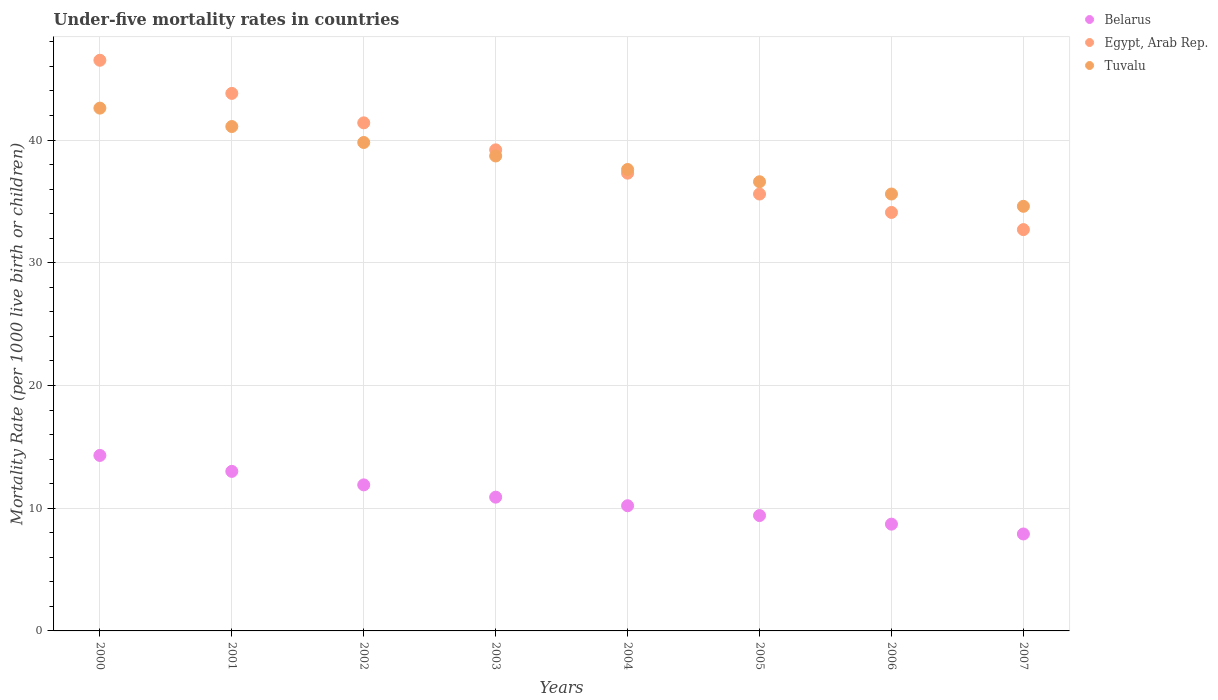What is the under-five mortality rate in Tuvalu in 2002?
Give a very brief answer. 39.8. Across all years, what is the maximum under-five mortality rate in Tuvalu?
Provide a short and direct response. 42.6. In which year was the under-five mortality rate in Tuvalu maximum?
Offer a very short reply. 2000. In which year was the under-five mortality rate in Egypt, Arab Rep. minimum?
Your answer should be very brief. 2007. What is the total under-five mortality rate in Egypt, Arab Rep. in the graph?
Provide a succinct answer. 310.6. What is the difference between the under-five mortality rate in Belarus in 2002 and that in 2006?
Offer a terse response. 3.2. What is the difference between the under-five mortality rate in Tuvalu in 2002 and the under-five mortality rate in Egypt, Arab Rep. in 2003?
Offer a very short reply. 0.6. What is the average under-five mortality rate in Tuvalu per year?
Offer a terse response. 38.33. In the year 2005, what is the difference between the under-five mortality rate in Egypt, Arab Rep. and under-five mortality rate in Belarus?
Your response must be concise. 26.2. What is the ratio of the under-five mortality rate in Tuvalu in 2004 to that in 2005?
Offer a very short reply. 1.03. Is the under-five mortality rate in Egypt, Arab Rep. in 2000 less than that in 2003?
Provide a succinct answer. No. Is the difference between the under-five mortality rate in Egypt, Arab Rep. in 2002 and 2003 greater than the difference between the under-five mortality rate in Belarus in 2002 and 2003?
Your answer should be very brief. Yes. What is the difference between the highest and the second highest under-five mortality rate in Egypt, Arab Rep.?
Your answer should be very brief. 2.7. In how many years, is the under-five mortality rate in Egypt, Arab Rep. greater than the average under-five mortality rate in Egypt, Arab Rep. taken over all years?
Offer a terse response. 4. Is the sum of the under-five mortality rate in Tuvalu in 2002 and 2004 greater than the maximum under-five mortality rate in Egypt, Arab Rep. across all years?
Keep it short and to the point. Yes. Is the under-five mortality rate in Egypt, Arab Rep. strictly greater than the under-five mortality rate in Tuvalu over the years?
Give a very brief answer. No. Is the under-five mortality rate in Egypt, Arab Rep. strictly less than the under-five mortality rate in Tuvalu over the years?
Make the answer very short. No. How many dotlines are there?
Provide a succinct answer. 3. How are the legend labels stacked?
Offer a very short reply. Vertical. What is the title of the graph?
Your response must be concise. Under-five mortality rates in countries. Does "Bolivia" appear as one of the legend labels in the graph?
Your response must be concise. No. What is the label or title of the Y-axis?
Keep it short and to the point. Mortality Rate (per 1000 live birth or children). What is the Mortality Rate (per 1000 live birth or children) of Egypt, Arab Rep. in 2000?
Provide a short and direct response. 46.5. What is the Mortality Rate (per 1000 live birth or children) in Tuvalu in 2000?
Keep it short and to the point. 42.6. What is the Mortality Rate (per 1000 live birth or children) of Belarus in 2001?
Make the answer very short. 13. What is the Mortality Rate (per 1000 live birth or children) in Egypt, Arab Rep. in 2001?
Your answer should be very brief. 43.8. What is the Mortality Rate (per 1000 live birth or children) in Tuvalu in 2001?
Give a very brief answer. 41.1. What is the Mortality Rate (per 1000 live birth or children) of Egypt, Arab Rep. in 2002?
Provide a succinct answer. 41.4. What is the Mortality Rate (per 1000 live birth or children) in Tuvalu in 2002?
Your answer should be compact. 39.8. What is the Mortality Rate (per 1000 live birth or children) of Egypt, Arab Rep. in 2003?
Offer a very short reply. 39.2. What is the Mortality Rate (per 1000 live birth or children) in Tuvalu in 2003?
Your answer should be very brief. 38.7. What is the Mortality Rate (per 1000 live birth or children) in Egypt, Arab Rep. in 2004?
Your response must be concise. 37.3. What is the Mortality Rate (per 1000 live birth or children) in Tuvalu in 2004?
Offer a very short reply. 37.6. What is the Mortality Rate (per 1000 live birth or children) of Egypt, Arab Rep. in 2005?
Make the answer very short. 35.6. What is the Mortality Rate (per 1000 live birth or children) of Tuvalu in 2005?
Offer a very short reply. 36.6. What is the Mortality Rate (per 1000 live birth or children) of Egypt, Arab Rep. in 2006?
Your answer should be very brief. 34.1. What is the Mortality Rate (per 1000 live birth or children) of Tuvalu in 2006?
Provide a short and direct response. 35.6. What is the Mortality Rate (per 1000 live birth or children) in Belarus in 2007?
Your response must be concise. 7.9. What is the Mortality Rate (per 1000 live birth or children) in Egypt, Arab Rep. in 2007?
Offer a terse response. 32.7. What is the Mortality Rate (per 1000 live birth or children) in Tuvalu in 2007?
Your response must be concise. 34.6. Across all years, what is the maximum Mortality Rate (per 1000 live birth or children) of Egypt, Arab Rep.?
Give a very brief answer. 46.5. Across all years, what is the maximum Mortality Rate (per 1000 live birth or children) of Tuvalu?
Your response must be concise. 42.6. Across all years, what is the minimum Mortality Rate (per 1000 live birth or children) in Belarus?
Give a very brief answer. 7.9. Across all years, what is the minimum Mortality Rate (per 1000 live birth or children) of Egypt, Arab Rep.?
Provide a succinct answer. 32.7. Across all years, what is the minimum Mortality Rate (per 1000 live birth or children) of Tuvalu?
Make the answer very short. 34.6. What is the total Mortality Rate (per 1000 live birth or children) of Belarus in the graph?
Provide a short and direct response. 86.3. What is the total Mortality Rate (per 1000 live birth or children) in Egypt, Arab Rep. in the graph?
Offer a terse response. 310.6. What is the total Mortality Rate (per 1000 live birth or children) in Tuvalu in the graph?
Offer a terse response. 306.6. What is the difference between the Mortality Rate (per 1000 live birth or children) of Belarus in 2000 and that in 2001?
Offer a very short reply. 1.3. What is the difference between the Mortality Rate (per 1000 live birth or children) in Belarus in 2000 and that in 2002?
Your response must be concise. 2.4. What is the difference between the Mortality Rate (per 1000 live birth or children) in Tuvalu in 2000 and that in 2002?
Provide a succinct answer. 2.8. What is the difference between the Mortality Rate (per 1000 live birth or children) in Tuvalu in 2000 and that in 2003?
Give a very brief answer. 3.9. What is the difference between the Mortality Rate (per 1000 live birth or children) of Belarus in 2000 and that in 2004?
Give a very brief answer. 4.1. What is the difference between the Mortality Rate (per 1000 live birth or children) of Tuvalu in 2000 and that in 2004?
Provide a short and direct response. 5. What is the difference between the Mortality Rate (per 1000 live birth or children) in Belarus in 2000 and that in 2005?
Offer a very short reply. 4.9. What is the difference between the Mortality Rate (per 1000 live birth or children) of Tuvalu in 2000 and that in 2005?
Your answer should be compact. 6. What is the difference between the Mortality Rate (per 1000 live birth or children) in Belarus in 2000 and that in 2006?
Your answer should be compact. 5.6. What is the difference between the Mortality Rate (per 1000 live birth or children) in Egypt, Arab Rep. in 2000 and that in 2006?
Provide a succinct answer. 12.4. What is the difference between the Mortality Rate (per 1000 live birth or children) in Tuvalu in 2000 and that in 2006?
Ensure brevity in your answer.  7. What is the difference between the Mortality Rate (per 1000 live birth or children) in Egypt, Arab Rep. in 2000 and that in 2007?
Give a very brief answer. 13.8. What is the difference between the Mortality Rate (per 1000 live birth or children) in Belarus in 2001 and that in 2002?
Give a very brief answer. 1.1. What is the difference between the Mortality Rate (per 1000 live birth or children) of Egypt, Arab Rep. in 2001 and that in 2003?
Provide a succinct answer. 4.6. What is the difference between the Mortality Rate (per 1000 live birth or children) of Tuvalu in 2001 and that in 2003?
Provide a short and direct response. 2.4. What is the difference between the Mortality Rate (per 1000 live birth or children) in Belarus in 2001 and that in 2004?
Your answer should be very brief. 2.8. What is the difference between the Mortality Rate (per 1000 live birth or children) of Egypt, Arab Rep. in 2001 and that in 2004?
Keep it short and to the point. 6.5. What is the difference between the Mortality Rate (per 1000 live birth or children) in Belarus in 2001 and that in 2006?
Your answer should be compact. 4.3. What is the difference between the Mortality Rate (per 1000 live birth or children) of Belarus in 2001 and that in 2007?
Provide a succinct answer. 5.1. What is the difference between the Mortality Rate (per 1000 live birth or children) in Egypt, Arab Rep. in 2001 and that in 2007?
Offer a very short reply. 11.1. What is the difference between the Mortality Rate (per 1000 live birth or children) in Belarus in 2002 and that in 2003?
Your response must be concise. 1. What is the difference between the Mortality Rate (per 1000 live birth or children) of Egypt, Arab Rep. in 2002 and that in 2003?
Your answer should be compact. 2.2. What is the difference between the Mortality Rate (per 1000 live birth or children) in Belarus in 2002 and that in 2004?
Your answer should be compact. 1.7. What is the difference between the Mortality Rate (per 1000 live birth or children) in Egypt, Arab Rep. in 2002 and that in 2004?
Your answer should be very brief. 4.1. What is the difference between the Mortality Rate (per 1000 live birth or children) of Tuvalu in 2002 and that in 2004?
Provide a succinct answer. 2.2. What is the difference between the Mortality Rate (per 1000 live birth or children) in Belarus in 2002 and that in 2005?
Ensure brevity in your answer.  2.5. What is the difference between the Mortality Rate (per 1000 live birth or children) in Egypt, Arab Rep. in 2002 and that in 2005?
Provide a succinct answer. 5.8. What is the difference between the Mortality Rate (per 1000 live birth or children) in Tuvalu in 2002 and that in 2005?
Make the answer very short. 3.2. What is the difference between the Mortality Rate (per 1000 live birth or children) of Belarus in 2002 and that in 2006?
Make the answer very short. 3.2. What is the difference between the Mortality Rate (per 1000 live birth or children) in Egypt, Arab Rep. in 2002 and that in 2006?
Provide a short and direct response. 7.3. What is the difference between the Mortality Rate (per 1000 live birth or children) in Egypt, Arab Rep. in 2002 and that in 2007?
Your answer should be very brief. 8.7. What is the difference between the Mortality Rate (per 1000 live birth or children) in Egypt, Arab Rep. in 2003 and that in 2004?
Your answer should be compact. 1.9. What is the difference between the Mortality Rate (per 1000 live birth or children) of Tuvalu in 2003 and that in 2004?
Provide a short and direct response. 1.1. What is the difference between the Mortality Rate (per 1000 live birth or children) of Belarus in 2003 and that in 2005?
Ensure brevity in your answer.  1.5. What is the difference between the Mortality Rate (per 1000 live birth or children) in Egypt, Arab Rep. in 2003 and that in 2005?
Make the answer very short. 3.6. What is the difference between the Mortality Rate (per 1000 live birth or children) in Egypt, Arab Rep. in 2003 and that in 2006?
Provide a short and direct response. 5.1. What is the difference between the Mortality Rate (per 1000 live birth or children) of Egypt, Arab Rep. in 2003 and that in 2007?
Provide a short and direct response. 6.5. What is the difference between the Mortality Rate (per 1000 live birth or children) of Egypt, Arab Rep. in 2004 and that in 2006?
Keep it short and to the point. 3.2. What is the difference between the Mortality Rate (per 1000 live birth or children) in Tuvalu in 2004 and that in 2006?
Provide a succinct answer. 2. What is the difference between the Mortality Rate (per 1000 live birth or children) in Egypt, Arab Rep. in 2004 and that in 2007?
Ensure brevity in your answer.  4.6. What is the difference between the Mortality Rate (per 1000 live birth or children) in Belarus in 2005 and that in 2006?
Your response must be concise. 0.7. What is the difference between the Mortality Rate (per 1000 live birth or children) of Tuvalu in 2005 and that in 2006?
Offer a very short reply. 1. What is the difference between the Mortality Rate (per 1000 live birth or children) in Egypt, Arab Rep. in 2005 and that in 2007?
Your answer should be compact. 2.9. What is the difference between the Mortality Rate (per 1000 live birth or children) of Belarus in 2006 and that in 2007?
Offer a terse response. 0.8. What is the difference between the Mortality Rate (per 1000 live birth or children) of Belarus in 2000 and the Mortality Rate (per 1000 live birth or children) of Egypt, Arab Rep. in 2001?
Keep it short and to the point. -29.5. What is the difference between the Mortality Rate (per 1000 live birth or children) of Belarus in 2000 and the Mortality Rate (per 1000 live birth or children) of Tuvalu in 2001?
Make the answer very short. -26.8. What is the difference between the Mortality Rate (per 1000 live birth or children) in Belarus in 2000 and the Mortality Rate (per 1000 live birth or children) in Egypt, Arab Rep. in 2002?
Offer a very short reply. -27.1. What is the difference between the Mortality Rate (per 1000 live birth or children) of Belarus in 2000 and the Mortality Rate (per 1000 live birth or children) of Tuvalu in 2002?
Ensure brevity in your answer.  -25.5. What is the difference between the Mortality Rate (per 1000 live birth or children) of Belarus in 2000 and the Mortality Rate (per 1000 live birth or children) of Egypt, Arab Rep. in 2003?
Ensure brevity in your answer.  -24.9. What is the difference between the Mortality Rate (per 1000 live birth or children) in Belarus in 2000 and the Mortality Rate (per 1000 live birth or children) in Tuvalu in 2003?
Ensure brevity in your answer.  -24.4. What is the difference between the Mortality Rate (per 1000 live birth or children) in Egypt, Arab Rep. in 2000 and the Mortality Rate (per 1000 live birth or children) in Tuvalu in 2003?
Provide a short and direct response. 7.8. What is the difference between the Mortality Rate (per 1000 live birth or children) in Belarus in 2000 and the Mortality Rate (per 1000 live birth or children) in Tuvalu in 2004?
Your response must be concise. -23.3. What is the difference between the Mortality Rate (per 1000 live birth or children) in Egypt, Arab Rep. in 2000 and the Mortality Rate (per 1000 live birth or children) in Tuvalu in 2004?
Offer a terse response. 8.9. What is the difference between the Mortality Rate (per 1000 live birth or children) in Belarus in 2000 and the Mortality Rate (per 1000 live birth or children) in Egypt, Arab Rep. in 2005?
Offer a very short reply. -21.3. What is the difference between the Mortality Rate (per 1000 live birth or children) in Belarus in 2000 and the Mortality Rate (per 1000 live birth or children) in Tuvalu in 2005?
Your answer should be compact. -22.3. What is the difference between the Mortality Rate (per 1000 live birth or children) of Egypt, Arab Rep. in 2000 and the Mortality Rate (per 1000 live birth or children) of Tuvalu in 2005?
Give a very brief answer. 9.9. What is the difference between the Mortality Rate (per 1000 live birth or children) in Belarus in 2000 and the Mortality Rate (per 1000 live birth or children) in Egypt, Arab Rep. in 2006?
Keep it short and to the point. -19.8. What is the difference between the Mortality Rate (per 1000 live birth or children) of Belarus in 2000 and the Mortality Rate (per 1000 live birth or children) of Tuvalu in 2006?
Offer a very short reply. -21.3. What is the difference between the Mortality Rate (per 1000 live birth or children) of Egypt, Arab Rep. in 2000 and the Mortality Rate (per 1000 live birth or children) of Tuvalu in 2006?
Give a very brief answer. 10.9. What is the difference between the Mortality Rate (per 1000 live birth or children) of Belarus in 2000 and the Mortality Rate (per 1000 live birth or children) of Egypt, Arab Rep. in 2007?
Keep it short and to the point. -18.4. What is the difference between the Mortality Rate (per 1000 live birth or children) in Belarus in 2000 and the Mortality Rate (per 1000 live birth or children) in Tuvalu in 2007?
Give a very brief answer. -20.3. What is the difference between the Mortality Rate (per 1000 live birth or children) in Egypt, Arab Rep. in 2000 and the Mortality Rate (per 1000 live birth or children) in Tuvalu in 2007?
Your answer should be compact. 11.9. What is the difference between the Mortality Rate (per 1000 live birth or children) of Belarus in 2001 and the Mortality Rate (per 1000 live birth or children) of Egypt, Arab Rep. in 2002?
Make the answer very short. -28.4. What is the difference between the Mortality Rate (per 1000 live birth or children) of Belarus in 2001 and the Mortality Rate (per 1000 live birth or children) of Tuvalu in 2002?
Provide a short and direct response. -26.8. What is the difference between the Mortality Rate (per 1000 live birth or children) of Belarus in 2001 and the Mortality Rate (per 1000 live birth or children) of Egypt, Arab Rep. in 2003?
Give a very brief answer. -26.2. What is the difference between the Mortality Rate (per 1000 live birth or children) of Belarus in 2001 and the Mortality Rate (per 1000 live birth or children) of Tuvalu in 2003?
Offer a terse response. -25.7. What is the difference between the Mortality Rate (per 1000 live birth or children) of Egypt, Arab Rep. in 2001 and the Mortality Rate (per 1000 live birth or children) of Tuvalu in 2003?
Offer a terse response. 5.1. What is the difference between the Mortality Rate (per 1000 live birth or children) in Belarus in 2001 and the Mortality Rate (per 1000 live birth or children) in Egypt, Arab Rep. in 2004?
Offer a very short reply. -24.3. What is the difference between the Mortality Rate (per 1000 live birth or children) of Belarus in 2001 and the Mortality Rate (per 1000 live birth or children) of Tuvalu in 2004?
Ensure brevity in your answer.  -24.6. What is the difference between the Mortality Rate (per 1000 live birth or children) in Egypt, Arab Rep. in 2001 and the Mortality Rate (per 1000 live birth or children) in Tuvalu in 2004?
Ensure brevity in your answer.  6.2. What is the difference between the Mortality Rate (per 1000 live birth or children) of Belarus in 2001 and the Mortality Rate (per 1000 live birth or children) of Egypt, Arab Rep. in 2005?
Your response must be concise. -22.6. What is the difference between the Mortality Rate (per 1000 live birth or children) in Belarus in 2001 and the Mortality Rate (per 1000 live birth or children) in Tuvalu in 2005?
Offer a very short reply. -23.6. What is the difference between the Mortality Rate (per 1000 live birth or children) of Belarus in 2001 and the Mortality Rate (per 1000 live birth or children) of Egypt, Arab Rep. in 2006?
Your answer should be very brief. -21.1. What is the difference between the Mortality Rate (per 1000 live birth or children) in Belarus in 2001 and the Mortality Rate (per 1000 live birth or children) in Tuvalu in 2006?
Give a very brief answer. -22.6. What is the difference between the Mortality Rate (per 1000 live birth or children) of Egypt, Arab Rep. in 2001 and the Mortality Rate (per 1000 live birth or children) of Tuvalu in 2006?
Provide a succinct answer. 8.2. What is the difference between the Mortality Rate (per 1000 live birth or children) in Belarus in 2001 and the Mortality Rate (per 1000 live birth or children) in Egypt, Arab Rep. in 2007?
Your answer should be compact. -19.7. What is the difference between the Mortality Rate (per 1000 live birth or children) in Belarus in 2001 and the Mortality Rate (per 1000 live birth or children) in Tuvalu in 2007?
Keep it short and to the point. -21.6. What is the difference between the Mortality Rate (per 1000 live birth or children) in Egypt, Arab Rep. in 2001 and the Mortality Rate (per 1000 live birth or children) in Tuvalu in 2007?
Provide a short and direct response. 9.2. What is the difference between the Mortality Rate (per 1000 live birth or children) of Belarus in 2002 and the Mortality Rate (per 1000 live birth or children) of Egypt, Arab Rep. in 2003?
Keep it short and to the point. -27.3. What is the difference between the Mortality Rate (per 1000 live birth or children) of Belarus in 2002 and the Mortality Rate (per 1000 live birth or children) of Tuvalu in 2003?
Make the answer very short. -26.8. What is the difference between the Mortality Rate (per 1000 live birth or children) of Egypt, Arab Rep. in 2002 and the Mortality Rate (per 1000 live birth or children) of Tuvalu in 2003?
Provide a short and direct response. 2.7. What is the difference between the Mortality Rate (per 1000 live birth or children) in Belarus in 2002 and the Mortality Rate (per 1000 live birth or children) in Egypt, Arab Rep. in 2004?
Your answer should be very brief. -25.4. What is the difference between the Mortality Rate (per 1000 live birth or children) of Belarus in 2002 and the Mortality Rate (per 1000 live birth or children) of Tuvalu in 2004?
Offer a very short reply. -25.7. What is the difference between the Mortality Rate (per 1000 live birth or children) of Belarus in 2002 and the Mortality Rate (per 1000 live birth or children) of Egypt, Arab Rep. in 2005?
Give a very brief answer. -23.7. What is the difference between the Mortality Rate (per 1000 live birth or children) in Belarus in 2002 and the Mortality Rate (per 1000 live birth or children) in Tuvalu in 2005?
Your response must be concise. -24.7. What is the difference between the Mortality Rate (per 1000 live birth or children) of Egypt, Arab Rep. in 2002 and the Mortality Rate (per 1000 live birth or children) of Tuvalu in 2005?
Make the answer very short. 4.8. What is the difference between the Mortality Rate (per 1000 live birth or children) in Belarus in 2002 and the Mortality Rate (per 1000 live birth or children) in Egypt, Arab Rep. in 2006?
Your response must be concise. -22.2. What is the difference between the Mortality Rate (per 1000 live birth or children) in Belarus in 2002 and the Mortality Rate (per 1000 live birth or children) in Tuvalu in 2006?
Make the answer very short. -23.7. What is the difference between the Mortality Rate (per 1000 live birth or children) of Egypt, Arab Rep. in 2002 and the Mortality Rate (per 1000 live birth or children) of Tuvalu in 2006?
Keep it short and to the point. 5.8. What is the difference between the Mortality Rate (per 1000 live birth or children) in Belarus in 2002 and the Mortality Rate (per 1000 live birth or children) in Egypt, Arab Rep. in 2007?
Ensure brevity in your answer.  -20.8. What is the difference between the Mortality Rate (per 1000 live birth or children) of Belarus in 2002 and the Mortality Rate (per 1000 live birth or children) of Tuvalu in 2007?
Offer a very short reply. -22.7. What is the difference between the Mortality Rate (per 1000 live birth or children) of Belarus in 2003 and the Mortality Rate (per 1000 live birth or children) of Egypt, Arab Rep. in 2004?
Your response must be concise. -26.4. What is the difference between the Mortality Rate (per 1000 live birth or children) of Belarus in 2003 and the Mortality Rate (per 1000 live birth or children) of Tuvalu in 2004?
Provide a short and direct response. -26.7. What is the difference between the Mortality Rate (per 1000 live birth or children) in Egypt, Arab Rep. in 2003 and the Mortality Rate (per 1000 live birth or children) in Tuvalu in 2004?
Your response must be concise. 1.6. What is the difference between the Mortality Rate (per 1000 live birth or children) in Belarus in 2003 and the Mortality Rate (per 1000 live birth or children) in Egypt, Arab Rep. in 2005?
Keep it short and to the point. -24.7. What is the difference between the Mortality Rate (per 1000 live birth or children) in Belarus in 2003 and the Mortality Rate (per 1000 live birth or children) in Tuvalu in 2005?
Make the answer very short. -25.7. What is the difference between the Mortality Rate (per 1000 live birth or children) of Egypt, Arab Rep. in 2003 and the Mortality Rate (per 1000 live birth or children) of Tuvalu in 2005?
Ensure brevity in your answer.  2.6. What is the difference between the Mortality Rate (per 1000 live birth or children) in Belarus in 2003 and the Mortality Rate (per 1000 live birth or children) in Egypt, Arab Rep. in 2006?
Your answer should be very brief. -23.2. What is the difference between the Mortality Rate (per 1000 live birth or children) of Belarus in 2003 and the Mortality Rate (per 1000 live birth or children) of Tuvalu in 2006?
Provide a succinct answer. -24.7. What is the difference between the Mortality Rate (per 1000 live birth or children) in Egypt, Arab Rep. in 2003 and the Mortality Rate (per 1000 live birth or children) in Tuvalu in 2006?
Your answer should be compact. 3.6. What is the difference between the Mortality Rate (per 1000 live birth or children) in Belarus in 2003 and the Mortality Rate (per 1000 live birth or children) in Egypt, Arab Rep. in 2007?
Ensure brevity in your answer.  -21.8. What is the difference between the Mortality Rate (per 1000 live birth or children) of Belarus in 2003 and the Mortality Rate (per 1000 live birth or children) of Tuvalu in 2007?
Ensure brevity in your answer.  -23.7. What is the difference between the Mortality Rate (per 1000 live birth or children) of Belarus in 2004 and the Mortality Rate (per 1000 live birth or children) of Egypt, Arab Rep. in 2005?
Keep it short and to the point. -25.4. What is the difference between the Mortality Rate (per 1000 live birth or children) in Belarus in 2004 and the Mortality Rate (per 1000 live birth or children) in Tuvalu in 2005?
Keep it short and to the point. -26.4. What is the difference between the Mortality Rate (per 1000 live birth or children) in Egypt, Arab Rep. in 2004 and the Mortality Rate (per 1000 live birth or children) in Tuvalu in 2005?
Your response must be concise. 0.7. What is the difference between the Mortality Rate (per 1000 live birth or children) of Belarus in 2004 and the Mortality Rate (per 1000 live birth or children) of Egypt, Arab Rep. in 2006?
Provide a succinct answer. -23.9. What is the difference between the Mortality Rate (per 1000 live birth or children) in Belarus in 2004 and the Mortality Rate (per 1000 live birth or children) in Tuvalu in 2006?
Your answer should be very brief. -25.4. What is the difference between the Mortality Rate (per 1000 live birth or children) in Egypt, Arab Rep. in 2004 and the Mortality Rate (per 1000 live birth or children) in Tuvalu in 2006?
Keep it short and to the point. 1.7. What is the difference between the Mortality Rate (per 1000 live birth or children) of Belarus in 2004 and the Mortality Rate (per 1000 live birth or children) of Egypt, Arab Rep. in 2007?
Give a very brief answer. -22.5. What is the difference between the Mortality Rate (per 1000 live birth or children) in Belarus in 2004 and the Mortality Rate (per 1000 live birth or children) in Tuvalu in 2007?
Provide a short and direct response. -24.4. What is the difference between the Mortality Rate (per 1000 live birth or children) of Egypt, Arab Rep. in 2004 and the Mortality Rate (per 1000 live birth or children) of Tuvalu in 2007?
Offer a very short reply. 2.7. What is the difference between the Mortality Rate (per 1000 live birth or children) in Belarus in 2005 and the Mortality Rate (per 1000 live birth or children) in Egypt, Arab Rep. in 2006?
Offer a very short reply. -24.7. What is the difference between the Mortality Rate (per 1000 live birth or children) of Belarus in 2005 and the Mortality Rate (per 1000 live birth or children) of Tuvalu in 2006?
Ensure brevity in your answer.  -26.2. What is the difference between the Mortality Rate (per 1000 live birth or children) of Belarus in 2005 and the Mortality Rate (per 1000 live birth or children) of Egypt, Arab Rep. in 2007?
Give a very brief answer. -23.3. What is the difference between the Mortality Rate (per 1000 live birth or children) in Belarus in 2005 and the Mortality Rate (per 1000 live birth or children) in Tuvalu in 2007?
Your answer should be very brief. -25.2. What is the difference between the Mortality Rate (per 1000 live birth or children) in Egypt, Arab Rep. in 2005 and the Mortality Rate (per 1000 live birth or children) in Tuvalu in 2007?
Your answer should be very brief. 1. What is the difference between the Mortality Rate (per 1000 live birth or children) of Belarus in 2006 and the Mortality Rate (per 1000 live birth or children) of Tuvalu in 2007?
Your answer should be very brief. -25.9. What is the difference between the Mortality Rate (per 1000 live birth or children) in Egypt, Arab Rep. in 2006 and the Mortality Rate (per 1000 live birth or children) in Tuvalu in 2007?
Provide a short and direct response. -0.5. What is the average Mortality Rate (per 1000 live birth or children) of Belarus per year?
Keep it short and to the point. 10.79. What is the average Mortality Rate (per 1000 live birth or children) of Egypt, Arab Rep. per year?
Ensure brevity in your answer.  38.83. What is the average Mortality Rate (per 1000 live birth or children) of Tuvalu per year?
Make the answer very short. 38.33. In the year 2000, what is the difference between the Mortality Rate (per 1000 live birth or children) of Belarus and Mortality Rate (per 1000 live birth or children) of Egypt, Arab Rep.?
Your answer should be very brief. -32.2. In the year 2000, what is the difference between the Mortality Rate (per 1000 live birth or children) of Belarus and Mortality Rate (per 1000 live birth or children) of Tuvalu?
Give a very brief answer. -28.3. In the year 2001, what is the difference between the Mortality Rate (per 1000 live birth or children) of Belarus and Mortality Rate (per 1000 live birth or children) of Egypt, Arab Rep.?
Your answer should be very brief. -30.8. In the year 2001, what is the difference between the Mortality Rate (per 1000 live birth or children) in Belarus and Mortality Rate (per 1000 live birth or children) in Tuvalu?
Give a very brief answer. -28.1. In the year 2002, what is the difference between the Mortality Rate (per 1000 live birth or children) of Belarus and Mortality Rate (per 1000 live birth or children) of Egypt, Arab Rep.?
Provide a succinct answer. -29.5. In the year 2002, what is the difference between the Mortality Rate (per 1000 live birth or children) in Belarus and Mortality Rate (per 1000 live birth or children) in Tuvalu?
Keep it short and to the point. -27.9. In the year 2002, what is the difference between the Mortality Rate (per 1000 live birth or children) of Egypt, Arab Rep. and Mortality Rate (per 1000 live birth or children) of Tuvalu?
Ensure brevity in your answer.  1.6. In the year 2003, what is the difference between the Mortality Rate (per 1000 live birth or children) of Belarus and Mortality Rate (per 1000 live birth or children) of Egypt, Arab Rep.?
Your response must be concise. -28.3. In the year 2003, what is the difference between the Mortality Rate (per 1000 live birth or children) of Belarus and Mortality Rate (per 1000 live birth or children) of Tuvalu?
Provide a succinct answer. -27.8. In the year 2004, what is the difference between the Mortality Rate (per 1000 live birth or children) in Belarus and Mortality Rate (per 1000 live birth or children) in Egypt, Arab Rep.?
Your response must be concise. -27.1. In the year 2004, what is the difference between the Mortality Rate (per 1000 live birth or children) of Belarus and Mortality Rate (per 1000 live birth or children) of Tuvalu?
Ensure brevity in your answer.  -27.4. In the year 2004, what is the difference between the Mortality Rate (per 1000 live birth or children) in Egypt, Arab Rep. and Mortality Rate (per 1000 live birth or children) in Tuvalu?
Offer a very short reply. -0.3. In the year 2005, what is the difference between the Mortality Rate (per 1000 live birth or children) of Belarus and Mortality Rate (per 1000 live birth or children) of Egypt, Arab Rep.?
Offer a very short reply. -26.2. In the year 2005, what is the difference between the Mortality Rate (per 1000 live birth or children) of Belarus and Mortality Rate (per 1000 live birth or children) of Tuvalu?
Your answer should be very brief. -27.2. In the year 2005, what is the difference between the Mortality Rate (per 1000 live birth or children) in Egypt, Arab Rep. and Mortality Rate (per 1000 live birth or children) in Tuvalu?
Keep it short and to the point. -1. In the year 2006, what is the difference between the Mortality Rate (per 1000 live birth or children) in Belarus and Mortality Rate (per 1000 live birth or children) in Egypt, Arab Rep.?
Offer a very short reply. -25.4. In the year 2006, what is the difference between the Mortality Rate (per 1000 live birth or children) of Belarus and Mortality Rate (per 1000 live birth or children) of Tuvalu?
Provide a succinct answer. -26.9. In the year 2006, what is the difference between the Mortality Rate (per 1000 live birth or children) in Egypt, Arab Rep. and Mortality Rate (per 1000 live birth or children) in Tuvalu?
Provide a succinct answer. -1.5. In the year 2007, what is the difference between the Mortality Rate (per 1000 live birth or children) of Belarus and Mortality Rate (per 1000 live birth or children) of Egypt, Arab Rep.?
Keep it short and to the point. -24.8. In the year 2007, what is the difference between the Mortality Rate (per 1000 live birth or children) of Belarus and Mortality Rate (per 1000 live birth or children) of Tuvalu?
Offer a very short reply. -26.7. What is the ratio of the Mortality Rate (per 1000 live birth or children) in Egypt, Arab Rep. in 2000 to that in 2001?
Your response must be concise. 1.06. What is the ratio of the Mortality Rate (per 1000 live birth or children) of Tuvalu in 2000 to that in 2001?
Provide a short and direct response. 1.04. What is the ratio of the Mortality Rate (per 1000 live birth or children) of Belarus in 2000 to that in 2002?
Provide a succinct answer. 1.2. What is the ratio of the Mortality Rate (per 1000 live birth or children) of Egypt, Arab Rep. in 2000 to that in 2002?
Your answer should be compact. 1.12. What is the ratio of the Mortality Rate (per 1000 live birth or children) of Tuvalu in 2000 to that in 2002?
Give a very brief answer. 1.07. What is the ratio of the Mortality Rate (per 1000 live birth or children) in Belarus in 2000 to that in 2003?
Make the answer very short. 1.31. What is the ratio of the Mortality Rate (per 1000 live birth or children) in Egypt, Arab Rep. in 2000 to that in 2003?
Provide a short and direct response. 1.19. What is the ratio of the Mortality Rate (per 1000 live birth or children) in Tuvalu in 2000 to that in 2003?
Offer a terse response. 1.1. What is the ratio of the Mortality Rate (per 1000 live birth or children) of Belarus in 2000 to that in 2004?
Your answer should be compact. 1.4. What is the ratio of the Mortality Rate (per 1000 live birth or children) in Egypt, Arab Rep. in 2000 to that in 2004?
Your answer should be compact. 1.25. What is the ratio of the Mortality Rate (per 1000 live birth or children) of Tuvalu in 2000 to that in 2004?
Ensure brevity in your answer.  1.13. What is the ratio of the Mortality Rate (per 1000 live birth or children) in Belarus in 2000 to that in 2005?
Ensure brevity in your answer.  1.52. What is the ratio of the Mortality Rate (per 1000 live birth or children) in Egypt, Arab Rep. in 2000 to that in 2005?
Keep it short and to the point. 1.31. What is the ratio of the Mortality Rate (per 1000 live birth or children) of Tuvalu in 2000 to that in 2005?
Keep it short and to the point. 1.16. What is the ratio of the Mortality Rate (per 1000 live birth or children) of Belarus in 2000 to that in 2006?
Offer a terse response. 1.64. What is the ratio of the Mortality Rate (per 1000 live birth or children) of Egypt, Arab Rep. in 2000 to that in 2006?
Your response must be concise. 1.36. What is the ratio of the Mortality Rate (per 1000 live birth or children) in Tuvalu in 2000 to that in 2006?
Your response must be concise. 1.2. What is the ratio of the Mortality Rate (per 1000 live birth or children) in Belarus in 2000 to that in 2007?
Your answer should be compact. 1.81. What is the ratio of the Mortality Rate (per 1000 live birth or children) in Egypt, Arab Rep. in 2000 to that in 2007?
Your answer should be very brief. 1.42. What is the ratio of the Mortality Rate (per 1000 live birth or children) of Tuvalu in 2000 to that in 2007?
Your answer should be very brief. 1.23. What is the ratio of the Mortality Rate (per 1000 live birth or children) in Belarus in 2001 to that in 2002?
Ensure brevity in your answer.  1.09. What is the ratio of the Mortality Rate (per 1000 live birth or children) in Egypt, Arab Rep. in 2001 to that in 2002?
Your answer should be very brief. 1.06. What is the ratio of the Mortality Rate (per 1000 live birth or children) of Tuvalu in 2001 to that in 2002?
Ensure brevity in your answer.  1.03. What is the ratio of the Mortality Rate (per 1000 live birth or children) in Belarus in 2001 to that in 2003?
Provide a short and direct response. 1.19. What is the ratio of the Mortality Rate (per 1000 live birth or children) in Egypt, Arab Rep. in 2001 to that in 2003?
Provide a succinct answer. 1.12. What is the ratio of the Mortality Rate (per 1000 live birth or children) of Tuvalu in 2001 to that in 2003?
Give a very brief answer. 1.06. What is the ratio of the Mortality Rate (per 1000 live birth or children) of Belarus in 2001 to that in 2004?
Provide a short and direct response. 1.27. What is the ratio of the Mortality Rate (per 1000 live birth or children) of Egypt, Arab Rep. in 2001 to that in 2004?
Keep it short and to the point. 1.17. What is the ratio of the Mortality Rate (per 1000 live birth or children) in Tuvalu in 2001 to that in 2004?
Give a very brief answer. 1.09. What is the ratio of the Mortality Rate (per 1000 live birth or children) in Belarus in 2001 to that in 2005?
Give a very brief answer. 1.38. What is the ratio of the Mortality Rate (per 1000 live birth or children) of Egypt, Arab Rep. in 2001 to that in 2005?
Your answer should be compact. 1.23. What is the ratio of the Mortality Rate (per 1000 live birth or children) in Tuvalu in 2001 to that in 2005?
Provide a short and direct response. 1.12. What is the ratio of the Mortality Rate (per 1000 live birth or children) of Belarus in 2001 to that in 2006?
Offer a terse response. 1.49. What is the ratio of the Mortality Rate (per 1000 live birth or children) of Egypt, Arab Rep. in 2001 to that in 2006?
Give a very brief answer. 1.28. What is the ratio of the Mortality Rate (per 1000 live birth or children) in Tuvalu in 2001 to that in 2006?
Make the answer very short. 1.15. What is the ratio of the Mortality Rate (per 1000 live birth or children) in Belarus in 2001 to that in 2007?
Provide a short and direct response. 1.65. What is the ratio of the Mortality Rate (per 1000 live birth or children) in Egypt, Arab Rep. in 2001 to that in 2007?
Offer a terse response. 1.34. What is the ratio of the Mortality Rate (per 1000 live birth or children) of Tuvalu in 2001 to that in 2007?
Offer a terse response. 1.19. What is the ratio of the Mortality Rate (per 1000 live birth or children) in Belarus in 2002 to that in 2003?
Your answer should be very brief. 1.09. What is the ratio of the Mortality Rate (per 1000 live birth or children) in Egypt, Arab Rep. in 2002 to that in 2003?
Give a very brief answer. 1.06. What is the ratio of the Mortality Rate (per 1000 live birth or children) in Tuvalu in 2002 to that in 2003?
Your answer should be compact. 1.03. What is the ratio of the Mortality Rate (per 1000 live birth or children) of Egypt, Arab Rep. in 2002 to that in 2004?
Offer a terse response. 1.11. What is the ratio of the Mortality Rate (per 1000 live birth or children) of Tuvalu in 2002 to that in 2004?
Offer a very short reply. 1.06. What is the ratio of the Mortality Rate (per 1000 live birth or children) in Belarus in 2002 to that in 2005?
Offer a very short reply. 1.27. What is the ratio of the Mortality Rate (per 1000 live birth or children) of Egypt, Arab Rep. in 2002 to that in 2005?
Give a very brief answer. 1.16. What is the ratio of the Mortality Rate (per 1000 live birth or children) of Tuvalu in 2002 to that in 2005?
Make the answer very short. 1.09. What is the ratio of the Mortality Rate (per 1000 live birth or children) of Belarus in 2002 to that in 2006?
Offer a very short reply. 1.37. What is the ratio of the Mortality Rate (per 1000 live birth or children) in Egypt, Arab Rep. in 2002 to that in 2006?
Your response must be concise. 1.21. What is the ratio of the Mortality Rate (per 1000 live birth or children) in Tuvalu in 2002 to that in 2006?
Make the answer very short. 1.12. What is the ratio of the Mortality Rate (per 1000 live birth or children) of Belarus in 2002 to that in 2007?
Provide a succinct answer. 1.51. What is the ratio of the Mortality Rate (per 1000 live birth or children) of Egypt, Arab Rep. in 2002 to that in 2007?
Provide a succinct answer. 1.27. What is the ratio of the Mortality Rate (per 1000 live birth or children) in Tuvalu in 2002 to that in 2007?
Your answer should be compact. 1.15. What is the ratio of the Mortality Rate (per 1000 live birth or children) of Belarus in 2003 to that in 2004?
Give a very brief answer. 1.07. What is the ratio of the Mortality Rate (per 1000 live birth or children) in Egypt, Arab Rep. in 2003 to that in 2004?
Your answer should be very brief. 1.05. What is the ratio of the Mortality Rate (per 1000 live birth or children) of Tuvalu in 2003 to that in 2004?
Offer a very short reply. 1.03. What is the ratio of the Mortality Rate (per 1000 live birth or children) of Belarus in 2003 to that in 2005?
Make the answer very short. 1.16. What is the ratio of the Mortality Rate (per 1000 live birth or children) of Egypt, Arab Rep. in 2003 to that in 2005?
Provide a succinct answer. 1.1. What is the ratio of the Mortality Rate (per 1000 live birth or children) of Tuvalu in 2003 to that in 2005?
Provide a succinct answer. 1.06. What is the ratio of the Mortality Rate (per 1000 live birth or children) of Belarus in 2003 to that in 2006?
Provide a succinct answer. 1.25. What is the ratio of the Mortality Rate (per 1000 live birth or children) of Egypt, Arab Rep. in 2003 to that in 2006?
Provide a succinct answer. 1.15. What is the ratio of the Mortality Rate (per 1000 live birth or children) in Tuvalu in 2003 to that in 2006?
Provide a short and direct response. 1.09. What is the ratio of the Mortality Rate (per 1000 live birth or children) of Belarus in 2003 to that in 2007?
Provide a succinct answer. 1.38. What is the ratio of the Mortality Rate (per 1000 live birth or children) of Egypt, Arab Rep. in 2003 to that in 2007?
Provide a succinct answer. 1.2. What is the ratio of the Mortality Rate (per 1000 live birth or children) in Tuvalu in 2003 to that in 2007?
Offer a very short reply. 1.12. What is the ratio of the Mortality Rate (per 1000 live birth or children) of Belarus in 2004 to that in 2005?
Your answer should be compact. 1.09. What is the ratio of the Mortality Rate (per 1000 live birth or children) in Egypt, Arab Rep. in 2004 to that in 2005?
Provide a succinct answer. 1.05. What is the ratio of the Mortality Rate (per 1000 live birth or children) in Tuvalu in 2004 to that in 2005?
Your answer should be very brief. 1.03. What is the ratio of the Mortality Rate (per 1000 live birth or children) of Belarus in 2004 to that in 2006?
Provide a short and direct response. 1.17. What is the ratio of the Mortality Rate (per 1000 live birth or children) of Egypt, Arab Rep. in 2004 to that in 2006?
Your answer should be very brief. 1.09. What is the ratio of the Mortality Rate (per 1000 live birth or children) of Tuvalu in 2004 to that in 2006?
Offer a terse response. 1.06. What is the ratio of the Mortality Rate (per 1000 live birth or children) of Belarus in 2004 to that in 2007?
Make the answer very short. 1.29. What is the ratio of the Mortality Rate (per 1000 live birth or children) in Egypt, Arab Rep. in 2004 to that in 2007?
Ensure brevity in your answer.  1.14. What is the ratio of the Mortality Rate (per 1000 live birth or children) of Tuvalu in 2004 to that in 2007?
Provide a succinct answer. 1.09. What is the ratio of the Mortality Rate (per 1000 live birth or children) of Belarus in 2005 to that in 2006?
Provide a succinct answer. 1.08. What is the ratio of the Mortality Rate (per 1000 live birth or children) of Egypt, Arab Rep. in 2005 to that in 2006?
Give a very brief answer. 1.04. What is the ratio of the Mortality Rate (per 1000 live birth or children) of Tuvalu in 2005 to that in 2006?
Make the answer very short. 1.03. What is the ratio of the Mortality Rate (per 1000 live birth or children) of Belarus in 2005 to that in 2007?
Your answer should be compact. 1.19. What is the ratio of the Mortality Rate (per 1000 live birth or children) in Egypt, Arab Rep. in 2005 to that in 2007?
Provide a short and direct response. 1.09. What is the ratio of the Mortality Rate (per 1000 live birth or children) in Tuvalu in 2005 to that in 2007?
Offer a terse response. 1.06. What is the ratio of the Mortality Rate (per 1000 live birth or children) in Belarus in 2006 to that in 2007?
Provide a short and direct response. 1.1. What is the ratio of the Mortality Rate (per 1000 live birth or children) of Egypt, Arab Rep. in 2006 to that in 2007?
Provide a succinct answer. 1.04. What is the ratio of the Mortality Rate (per 1000 live birth or children) of Tuvalu in 2006 to that in 2007?
Keep it short and to the point. 1.03. What is the difference between the highest and the second highest Mortality Rate (per 1000 live birth or children) in Belarus?
Offer a terse response. 1.3. What is the difference between the highest and the second highest Mortality Rate (per 1000 live birth or children) of Egypt, Arab Rep.?
Ensure brevity in your answer.  2.7. What is the difference between the highest and the lowest Mortality Rate (per 1000 live birth or children) in Belarus?
Offer a very short reply. 6.4. What is the difference between the highest and the lowest Mortality Rate (per 1000 live birth or children) of Egypt, Arab Rep.?
Keep it short and to the point. 13.8. What is the difference between the highest and the lowest Mortality Rate (per 1000 live birth or children) of Tuvalu?
Offer a very short reply. 8. 